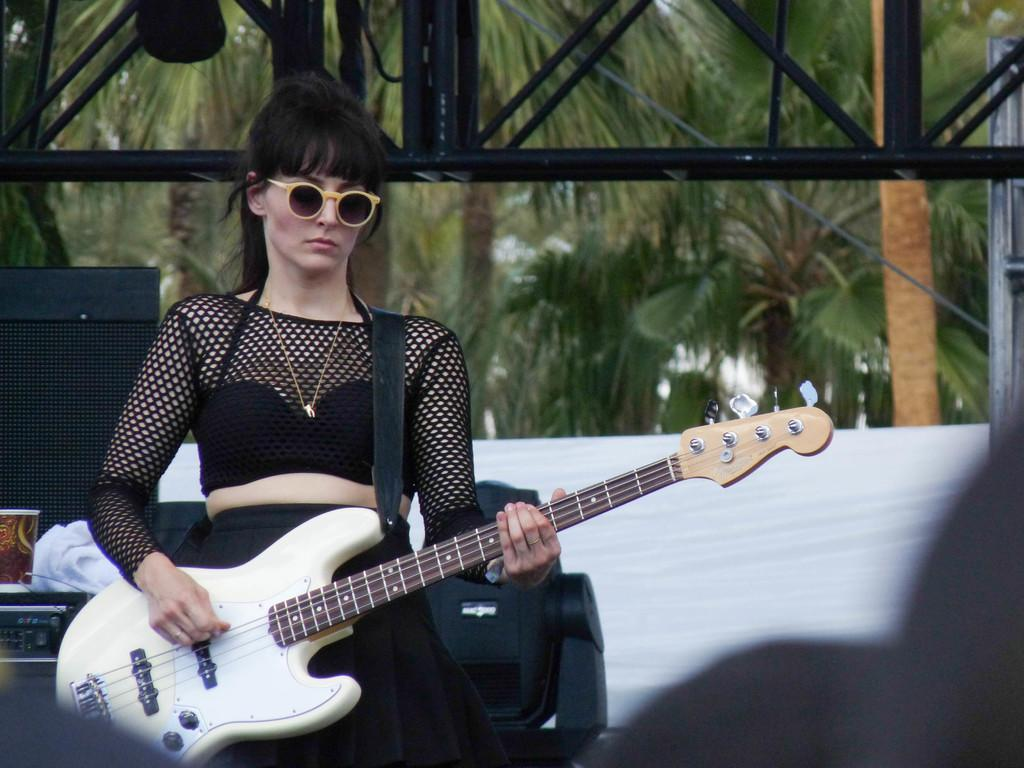Where was the image taken? The image is taken outdoors. Who is present in the image? There is a man in the image. What is the man wearing? The man is wearing a black dress. What is the man doing in the image? The man is standing on a stage and holding a guitar. What can be seen in the background of the image? There are music systems and trees in the background. What type of flesh can be seen in the image? There is no flesh visible in the image; it features a man wearing a black dress and holding a guitar on a stage. Is the man in the image a prisoner? There is no indication in the image that the man is a prisoner; he is standing on a stage and holding a guitar. 